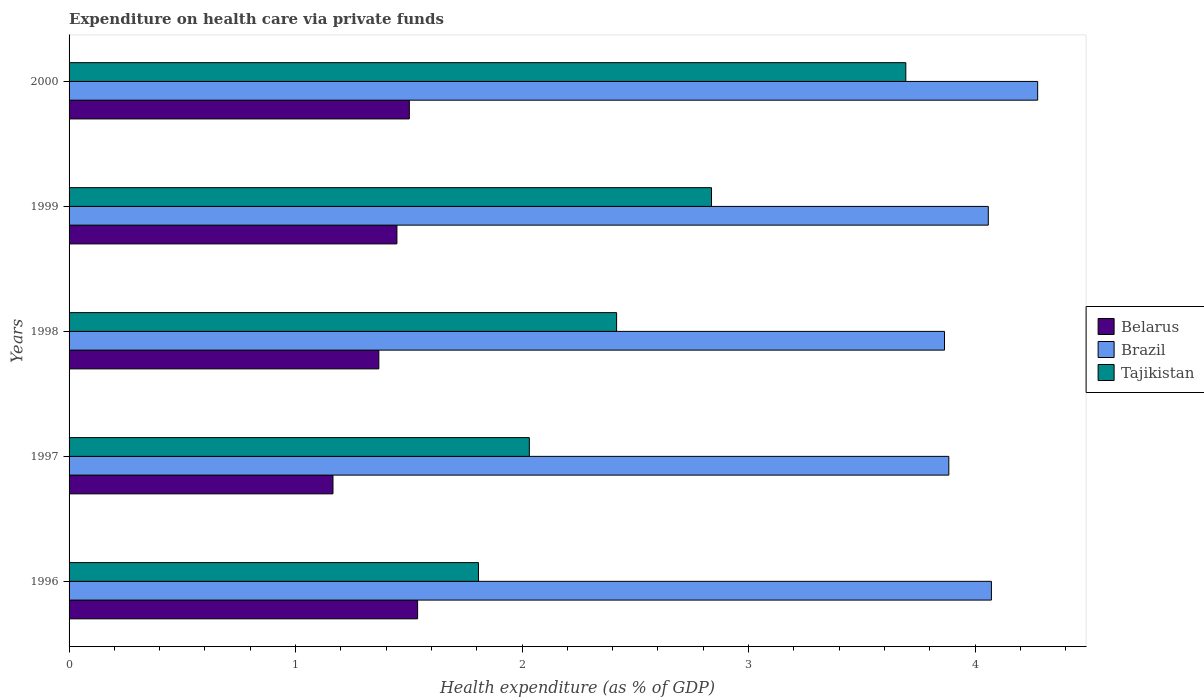How many different coloured bars are there?
Keep it short and to the point. 3. How many groups of bars are there?
Offer a very short reply. 5. Are the number of bars on each tick of the Y-axis equal?
Make the answer very short. Yes. How many bars are there on the 3rd tick from the top?
Keep it short and to the point. 3. How many bars are there on the 3rd tick from the bottom?
Provide a succinct answer. 3. What is the label of the 1st group of bars from the top?
Your response must be concise. 2000. In how many cases, is the number of bars for a given year not equal to the number of legend labels?
Offer a very short reply. 0. What is the expenditure made on health care in Tajikistan in 1998?
Your answer should be compact. 2.42. Across all years, what is the maximum expenditure made on health care in Tajikistan?
Offer a very short reply. 3.69. Across all years, what is the minimum expenditure made on health care in Brazil?
Offer a very short reply. 3.87. In which year was the expenditure made on health care in Belarus maximum?
Make the answer very short. 1996. What is the total expenditure made on health care in Tajikistan in the graph?
Your answer should be compact. 12.79. What is the difference between the expenditure made on health care in Belarus in 1996 and that in 1999?
Make the answer very short. 0.09. What is the difference between the expenditure made on health care in Belarus in 2000 and the expenditure made on health care in Tajikistan in 1997?
Ensure brevity in your answer.  -0.53. What is the average expenditure made on health care in Belarus per year?
Your answer should be very brief. 1.4. In the year 1999, what is the difference between the expenditure made on health care in Belarus and expenditure made on health care in Brazil?
Your answer should be compact. -2.61. What is the ratio of the expenditure made on health care in Tajikistan in 1996 to that in 2000?
Make the answer very short. 0.49. Is the difference between the expenditure made on health care in Belarus in 1997 and 2000 greater than the difference between the expenditure made on health care in Brazil in 1997 and 2000?
Your answer should be compact. Yes. What is the difference between the highest and the second highest expenditure made on health care in Belarus?
Give a very brief answer. 0.04. What is the difference between the highest and the lowest expenditure made on health care in Belarus?
Ensure brevity in your answer.  0.37. What does the 1st bar from the top in 1999 represents?
Provide a short and direct response. Tajikistan. What does the 1st bar from the bottom in 1996 represents?
Your answer should be very brief. Belarus. How many bars are there?
Your answer should be compact. 15. How many years are there in the graph?
Offer a very short reply. 5. Are the values on the major ticks of X-axis written in scientific E-notation?
Keep it short and to the point. No. Does the graph contain grids?
Make the answer very short. No. How are the legend labels stacked?
Offer a terse response. Vertical. What is the title of the graph?
Keep it short and to the point. Expenditure on health care via private funds. Does "Thailand" appear as one of the legend labels in the graph?
Your answer should be very brief. No. What is the label or title of the X-axis?
Keep it short and to the point. Health expenditure (as % of GDP). What is the Health expenditure (as % of GDP) in Belarus in 1996?
Ensure brevity in your answer.  1.54. What is the Health expenditure (as % of GDP) of Brazil in 1996?
Provide a short and direct response. 4.07. What is the Health expenditure (as % of GDP) of Tajikistan in 1996?
Provide a short and direct response. 1.81. What is the Health expenditure (as % of GDP) of Belarus in 1997?
Your answer should be very brief. 1.17. What is the Health expenditure (as % of GDP) in Brazil in 1997?
Make the answer very short. 3.88. What is the Health expenditure (as % of GDP) of Tajikistan in 1997?
Provide a succinct answer. 2.03. What is the Health expenditure (as % of GDP) in Belarus in 1998?
Provide a short and direct response. 1.37. What is the Health expenditure (as % of GDP) of Brazil in 1998?
Give a very brief answer. 3.87. What is the Health expenditure (as % of GDP) of Tajikistan in 1998?
Offer a terse response. 2.42. What is the Health expenditure (as % of GDP) in Belarus in 1999?
Offer a terse response. 1.45. What is the Health expenditure (as % of GDP) in Brazil in 1999?
Your answer should be very brief. 4.06. What is the Health expenditure (as % of GDP) in Tajikistan in 1999?
Your answer should be compact. 2.84. What is the Health expenditure (as % of GDP) in Belarus in 2000?
Your answer should be compact. 1.5. What is the Health expenditure (as % of GDP) of Brazil in 2000?
Your answer should be very brief. 4.28. What is the Health expenditure (as % of GDP) in Tajikistan in 2000?
Provide a short and direct response. 3.69. Across all years, what is the maximum Health expenditure (as % of GDP) in Belarus?
Provide a succinct answer. 1.54. Across all years, what is the maximum Health expenditure (as % of GDP) of Brazil?
Ensure brevity in your answer.  4.28. Across all years, what is the maximum Health expenditure (as % of GDP) of Tajikistan?
Give a very brief answer. 3.69. Across all years, what is the minimum Health expenditure (as % of GDP) of Belarus?
Provide a succinct answer. 1.17. Across all years, what is the minimum Health expenditure (as % of GDP) of Brazil?
Your answer should be very brief. 3.87. Across all years, what is the minimum Health expenditure (as % of GDP) of Tajikistan?
Your response must be concise. 1.81. What is the total Health expenditure (as % of GDP) of Belarus in the graph?
Keep it short and to the point. 7.02. What is the total Health expenditure (as % of GDP) of Brazil in the graph?
Provide a succinct answer. 20.16. What is the total Health expenditure (as % of GDP) of Tajikistan in the graph?
Your answer should be compact. 12.79. What is the difference between the Health expenditure (as % of GDP) of Belarus in 1996 and that in 1997?
Make the answer very short. 0.37. What is the difference between the Health expenditure (as % of GDP) of Brazil in 1996 and that in 1997?
Your answer should be compact. 0.19. What is the difference between the Health expenditure (as % of GDP) of Tajikistan in 1996 and that in 1997?
Keep it short and to the point. -0.22. What is the difference between the Health expenditure (as % of GDP) of Belarus in 1996 and that in 1998?
Provide a succinct answer. 0.17. What is the difference between the Health expenditure (as % of GDP) in Brazil in 1996 and that in 1998?
Your response must be concise. 0.21. What is the difference between the Health expenditure (as % of GDP) in Tajikistan in 1996 and that in 1998?
Make the answer very short. -0.61. What is the difference between the Health expenditure (as % of GDP) in Belarus in 1996 and that in 1999?
Your answer should be compact. 0.09. What is the difference between the Health expenditure (as % of GDP) of Brazil in 1996 and that in 1999?
Your answer should be compact. 0.01. What is the difference between the Health expenditure (as % of GDP) in Tajikistan in 1996 and that in 1999?
Give a very brief answer. -1.03. What is the difference between the Health expenditure (as % of GDP) of Belarus in 1996 and that in 2000?
Keep it short and to the point. 0.04. What is the difference between the Health expenditure (as % of GDP) of Brazil in 1996 and that in 2000?
Provide a succinct answer. -0.2. What is the difference between the Health expenditure (as % of GDP) of Tajikistan in 1996 and that in 2000?
Provide a succinct answer. -1.89. What is the difference between the Health expenditure (as % of GDP) of Belarus in 1997 and that in 1998?
Your answer should be compact. -0.2. What is the difference between the Health expenditure (as % of GDP) of Brazil in 1997 and that in 1998?
Provide a short and direct response. 0.02. What is the difference between the Health expenditure (as % of GDP) in Tajikistan in 1997 and that in 1998?
Offer a very short reply. -0.39. What is the difference between the Health expenditure (as % of GDP) of Belarus in 1997 and that in 1999?
Provide a succinct answer. -0.28. What is the difference between the Health expenditure (as % of GDP) of Brazil in 1997 and that in 1999?
Your response must be concise. -0.17. What is the difference between the Health expenditure (as % of GDP) of Tajikistan in 1997 and that in 1999?
Your answer should be very brief. -0.8. What is the difference between the Health expenditure (as % of GDP) of Belarus in 1997 and that in 2000?
Provide a short and direct response. -0.34. What is the difference between the Health expenditure (as % of GDP) in Brazil in 1997 and that in 2000?
Your answer should be very brief. -0.39. What is the difference between the Health expenditure (as % of GDP) in Tajikistan in 1997 and that in 2000?
Offer a very short reply. -1.66. What is the difference between the Health expenditure (as % of GDP) in Belarus in 1998 and that in 1999?
Offer a very short reply. -0.08. What is the difference between the Health expenditure (as % of GDP) of Brazil in 1998 and that in 1999?
Provide a short and direct response. -0.19. What is the difference between the Health expenditure (as % of GDP) in Tajikistan in 1998 and that in 1999?
Your answer should be compact. -0.42. What is the difference between the Health expenditure (as % of GDP) in Belarus in 1998 and that in 2000?
Give a very brief answer. -0.13. What is the difference between the Health expenditure (as % of GDP) of Brazil in 1998 and that in 2000?
Provide a short and direct response. -0.41. What is the difference between the Health expenditure (as % of GDP) in Tajikistan in 1998 and that in 2000?
Ensure brevity in your answer.  -1.28. What is the difference between the Health expenditure (as % of GDP) of Belarus in 1999 and that in 2000?
Provide a short and direct response. -0.05. What is the difference between the Health expenditure (as % of GDP) in Brazil in 1999 and that in 2000?
Offer a terse response. -0.22. What is the difference between the Health expenditure (as % of GDP) in Tajikistan in 1999 and that in 2000?
Give a very brief answer. -0.86. What is the difference between the Health expenditure (as % of GDP) in Belarus in 1996 and the Health expenditure (as % of GDP) in Brazil in 1997?
Give a very brief answer. -2.35. What is the difference between the Health expenditure (as % of GDP) in Belarus in 1996 and the Health expenditure (as % of GDP) in Tajikistan in 1997?
Provide a short and direct response. -0.49. What is the difference between the Health expenditure (as % of GDP) in Brazil in 1996 and the Health expenditure (as % of GDP) in Tajikistan in 1997?
Provide a short and direct response. 2.04. What is the difference between the Health expenditure (as % of GDP) of Belarus in 1996 and the Health expenditure (as % of GDP) of Brazil in 1998?
Provide a succinct answer. -2.33. What is the difference between the Health expenditure (as % of GDP) of Belarus in 1996 and the Health expenditure (as % of GDP) of Tajikistan in 1998?
Provide a short and direct response. -0.88. What is the difference between the Health expenditure (as % of GDP) in Brazil in 1996 and the Health expenditure (as % of GDP) in Tajikistan in 1998?
Your response must be concise. 1.65. What is the difference between the Health expenditure (as % of GDP) of Belarus in 1996 and the Health expenditure (as % of GDP) of Brazil in 1999?
Offer a terse response. -2.52. What is the difference between the Health expenditure (as % of GDP) of Belarus in 1996 and the Health expenditure (as % of GDP) of Tajikistan in 1999?
Offer a very short reply. -1.3. What is the difference between the Health expenditure (as % of GDP) in Brazil in 1996 and the Health expenditure (as % of GDP) in Tajikistan in 1999?
Your answer should be compact. 1.24. What is the difference between the Health expenditure (as % of GDP) of Belarus in 1996 and the Health expenditure (as % of GDP) of Brazil in 2000?
Ensure brevity in your answer.  -2.74. What is the difference between the Health expenditure (as % of GDP) in Belarus in 1996 and the Health expenditure (as % of GDP) in Tajikistan in 2000?
Your answer should be very brief. -2.16. What is the difference between the Health expenditure (as % of GDP) in Brazil in 1996 and the Health expenditure (as % of GDP) in Tajikistan in 2000?
Provide a short and direct response. 0.38. What is the difference between the Health expenditure (as % of GDP) in Belarus in 1997 and the Health expenditure (as % of GDP) in Brazil in 1998?
Give a very brief answer. -2.7. What is the difference between the Health expenditure (as % of GDP) of Belarus in 1997 and the Health expenditure (as % of GDP) of Tajikistan in 1998?
Your answer should be very brief. -1.25. What is the difference between the Health expenditure (as % of GDP) of Brazil in 1997 and the Health expenditure (as % of GDP) of Tajikistan in 1998?
Your response must be concise. 1.47. What is the difference between the Health expenditure (as % of GDP) of Belarus in 1997 and the Health expenditure (as % of GDP) of Brazil in 1999?
Ensure brevity in your answer.  -2.89. What is the difference between the Health expenditure (as % of GDP) of Belarus in 1997 and the Health expenditure (as % of GDP) of Tajikistan in 1999?
Offer a very short reply. -1.67. What is the difference between the Health expenditure (as % of GDP) in Brazil in 1997 and the Health expenditure (as % of GDP) in Tajikistan in 1999?
Your answer should be compact. 1.05. What is the difference between the Health expenditure (as % of GDP) of Belarus in 1997 and the Health expenditure (as % of GDP) of Brazil in 2000?
Offer a very short reply. -3.11. What is the difference between the Health expenditure (as % of GDP) in Belarus in 1997 and the Health expenditure (as % of GDP) in Tajikistan in 2000?
Keep it short and to the point. -2.53. What is the difference between the Health expenditure (as % of GDP) in Brazil in 1997 and the Health expenditure (as % of GDP) in Tajikistan in 2000?
Your answer should be compact. 0.19. What is the difference between the Health expenditure (as % of GDP) of Belarus in 1998 and the Health expenditure (as % of GDP) of Brazil in 1999?
Your answer should be compact. -2.69. What is the difference between the Health expenditure (as % of GDP) of Belarus in 1998 and the Health expenditure (as % of GDP) of Tajikistan in 1999?
Provide a short and direct response. -1.47. What is the difference between the Health expenditure (as % of GDP) of Brazil in 1998 and the Health expenditure (as % of GDP) of Tajikistan in 1999?
Offer a terse response. 1.03. What is the difference between the Health expenditure (as % of GDP) in Belarus in 1998 and the Health expenditure (as % of GDP) in Brazil in 2000?
Ensure brevity in your answer.  -2.91. What is the difference between the Health expenditure (as % of GDP) of Belarus in 1998 and the Health expenditure (as % of GDP) of Tajikistan in 2000?
Provide a short and direct response. -2.33. What is the difference between the Health expenditure (as % of GDP) of Brazil in 1998 and the Health expenditure (as % of GDP) of Tajikistan in 2000?
Offer a very short reply. 0.17. What is the difference between the Health expenditure (as % of GDP) of Belarus in 1999 and the Health expenditure (as % of GDP) of Brazil in 2000?
Give a very brief answer. -2.83. What is the difference between the Health expenditure (as % of GDP) in Belarus in 1999 and the Health expenditure (as % of GDP) in Tajikistan in 2000?
Offer a terse response. -2.25. What is the difference between the Health expenditure (as % of GDP) of Brazil in 1999 and the Health expenditure (as % of GDP) of Tajikistan in 2000?
Offer a very short reply. 0.36. What is the average Health expenditure (as % of GDP) in Belarus per year?
Provide a short and direct response. 1.4. What is the average Health expenditure (as % of GDP) of Brazil per year?
Provide a short and direct response. 4.03. What is the average Health expenditure (as % of GDP) in Tajikistan per year?
Your answer should be very brief. 2.56. In the year 1996, what is the difference between the Health expenditure (as % of GDP) in Belarus and Health expenditure (as % of GDP) in Brazil?
Offer a very short reply. -2.53. In the year 1996, what is the difference between the Health expenditure (as % of GDP) of Belarus and Health expenditure (as % of GDP) of Tajikistan?
Offer a terse response. -0.27. In the year 1996, what is the difference between the Health expenditure (as % of GDP) in Brazil and Health expenditure (as % of GDP) in Tajikistan?
Offer a terse response. 2.26. In the year 1997, what is the difference between the Health expenditure (as % of GDP) of Belarus and Health expenditure (as % of GDP) of Brazil?
Make the answer very short. -2.72. In the year 1997, what is the difference between the Health expenditure (as % of GDP) in Belarus and Health expenditure (as % of GDP) in Tajikistan?
Provide a short and direct response. -0.87. In the year 1997, what is the difference between the Health expenditure (as % of GDP) in Brazil and Health expenditure (as % of GDP) in Tajikistan?
Provide a short and direct response. 1.85. In the year 1998, what is the difference between the Health expenditure (as % of GDP) in Belarus and Health expenditure (as % of GDP) in Brazil?
Provide a succinct answer. -2.5. In the year 1998, what is the difference between the Health expenditure (as % of GDP) of Belarus and Health expenditure (as % of GDP) of Tajikistan?
Make the answer very short. -1.05. In the year 1998, what is the difference between the Health expenditure (as % of GDP) in Brazil and Health expenditure (as % of GDP) in Tajikistan?
Your answer should be very brief. 1.45. In the year 1999, what is the difference between the Health expenditure (as % of GDP) of Belarus and Health expenditure (as % of GDP) of Brazil?
Offer a very short reply. -2.61. In the year 1999, what is the difference between the Health expenditure (as % of GDP) of Belarus and Health expenditure (as % of GDP) of Tajikistan?
Make the answer very short. -1.39. In the year 1999, what is the difference between the Health expenditure (as % of GDP) of Brazil and Health expenditure (as % of GDP) of Tajikistan?
Give a very brief answer. 1.22. In the year 2000, what is the difference between the Health expenditure (as % of GDP) of Belarus and Health expenditure (as % of GDP) of Brazil?
Keep it short and to the point. -2.77. In the year 2000, what is the difference between the Health expenditure (as % of GDP) in Belarus and Health expenditure (as % of GDP) in Tajikistan?
Your answer should be very brief. -2.19. In the year 2000, what is the difference between the Health expenditure (as % of GDP) of Brazil and Health expenditure (as % of GDP) of Tajikistan?
Provide a short and direct response. 0.58. What is the ratio of the Health expenditure (as % of GDP) in Belarus in 1996 to that in 1997?
Provide a succinct answer. 1.32. What is the ratio of the Health expenditure (as % of GDP) of Brazil in 1996 to that in 1997?
Your answer should be very brief. 1.05. What is the ratio of the Health expenditure (as % of GDP) in Tajikistan in 1996 to that in 1997?
Your answer should be very brief. 0.89. What is the ratio of the Health expenditure (as % of GDP) in Belarus in 1996 to that in 1998?
Provide a short and direct response. 1.13. What is the ratio of the Health expenditure (as % of GDP) of Brazil in 1996 to that in 1998?
Keep it short and to the point. 1.05. What is the ratio of the Health expenditure (as % of GDP) of Tajikistan in 1996 to that in 1998?
Provide a short and direct response. 0.75. What is the ratio of the Health expenditure (as % of GDP) of Belarus in 1996 to that in 1999?
Provide a succinct answer. 1.06. What is the ratio of the Health expenditure (as % of GDP) in Tajikistan in 1996 to that in 1999?
Your response must be concise. 0.64. What is the ratio of the Health expenditure (as % of GDP) in Belarus in 1996 to that in 2000?
Offer a very short reply. 1.02. What is the ratio of the Health expenditure (as % of GDP) of Brazil in 1996 to that in 2000?
Provide a short and direct response. 0.95. What is the ratio of the Health expenditure (as % of GDP) in Tajikistan in 1996 to that in 2000?
Your response must be concise. 0.49. What is the ratio of the Health expenditure (as % of GDP) of Belarus in 1997 to that in 1998?
Your response must be concise. 0.85. What is the ratio of the Health expenditure (as % of GDP) of Brazil in 1997 to that in 1998?
Provide a short and direct response. 1. What is the ratio of the Health expenditure (as % of GDP) in Tajikistan in 1997 to that in 1998?
Your answer should be very brief. 0.84. What is the ratio of the Health expenditure (as % of GDP) of Belarus in 1997 to that in 1999?
Provide a succinct answer. 0.81. What is the ratio of the Health expenditure (as % of GDP) of Brazil in 1997 to that in 1999?
Provide a short and direct response. 0.96. What is the ratio of the Health expenditure (as % of GDP) in Tajikistan in 1997 to that in 1999?
Keep it short and to the point. 0.72. What is the ratio of the Health expenditure (as % of GDP) of Belarus in 1997 to that in 2000?
Offer a terse response. 0.78. What is the ratio of the Health expenditure (as % of GDP) of Brazil in 1997 to that in 2000?
Your answer should be very brief. 0.91. What is the ratio of the Health expenditure (as % of GDP) of Tajikistan in 1997 to that in 2000?
Provide a short and direct response. 0.55. What is the ratio of the Health expenditure (as % of GDP) in Belarus in 1998 to that in 1999?
Keep it short and to the point. 0.94. What is the ratio of the Health expenditure (as % of GDP) in Tajikistan in 1998 to that in 1999?
Keep it short and to the point. 0.85. What is the ratio of the Health expenditure (as % of GDP) of Belarus in 1998 to that in 2000?
Ensure brevity in your answer.  0.91. What is the ratio of the Health expenditure (as % of GDP) in Brazil in 1998 to that in 2000?
Give a very brief answer. 0.9. What is the ratio of the Health expenditure (as % of GDP) in Tajikistan in 1998 to that in 2000?
Your answer should be compact. 0.65. What is the ratio of the Health expenditure (as % of GDP) of Belarus in 1999 to that in 2000?
Provide a short and direct response. 0.96. What is the ratio of the Health expenditure (as % of GDP) in Brazil in 1999 to that in 2000?
Offer a terse response. 0.95. What is the ratio of the Health expenditure (as % of GDP) of Tajikistan in 1999 to that in 2000?
Offer a very short reply. 0.77. What is the difference between the highest and the second highest Health expenditure (as % of GDP) of Belarus?
Keep it short and to the point. 0.04. What is the difference between the highest and the second highest Health expenditure (as % of GDP) of Brazil?
Your answer should be very brief. 0.2. What is the difference between the highest and the second highest Health expenditure (as % of GDP) of Tajikistan?
Ensure brevity in your answer.  0.86. What is the difference between the highest and the lowest Health expenditure (as % of GDP) in Belarus?
Make the answer very short. 0.37. What is the difference between the highest and the lowest Health expenditure (as % of GDP) in Brazil?
Your answer should be very brief. 0.41. What is the difference between the highest and the lowest Health expenditure (as % of GDP) in Tajikistan?
Give a very brief answer. 1.89. 